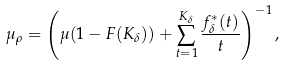<formula> <loc_0><loc_0><loc_500><loc_500>\mu _ { \rho } = \left ( \mu ( 1 - F ( K _ { \delta } ) ) + \sum _ { t = 1 } ^ { K _ { \delta } } \frac { f ^ { \ast } _ { \delta } ( t ) } { t } \right ) ^ { - 1 } ,</formula> 